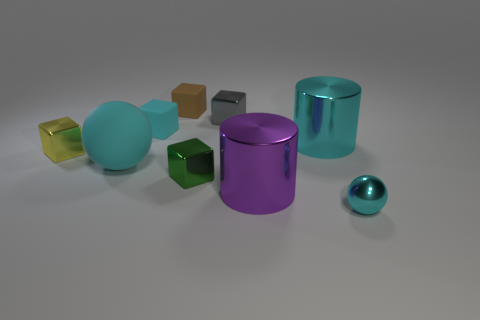Subtract all yellow cubes. How many cubes are left? 4 Subtract 1 blocks. How many blocks are left? 4 Subtract all brown cubes. How many cubes are left? 4 Subtract all red cubes. Subtract all gray balls. How many cubes are left? 5 Add 1 small gray blocks. How many objects exist? 10 Subtract all spheres. How many objects are left? 7 Subtract 0 red cylinders. How many objects are left? 9 Subtract all small cyan rubber blocks. Subtract all purple shiny objects. How many objects are left? 7 Add 6 purple things. How many purple things are left? 7 Add 3 tiny green cubes. How many tiny green cubes exist? 4 